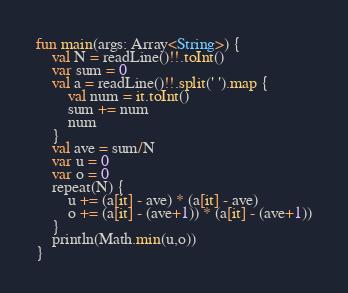Convert code to text. <code><loc_0><loc_0><loc_500><loc_500><_Kotlin_>fun main(args: Array<String>) {
    val N = readLine()!!.toInt()
    var sum = 0
    val a = readLine()!!.split(' ').map {
        val num = it.toInt()
        sum += num
        num
    }
    val ave = sum/N
    var u = 0
    var o = 0
    repeat(N) {
        u += (a[it] - ave) * (a[it] - ave)
        o += (a[it] - (ave+1)) * (a[it] - (ave+1))
    }
    println(Math.min(u,o))
}
</code> 